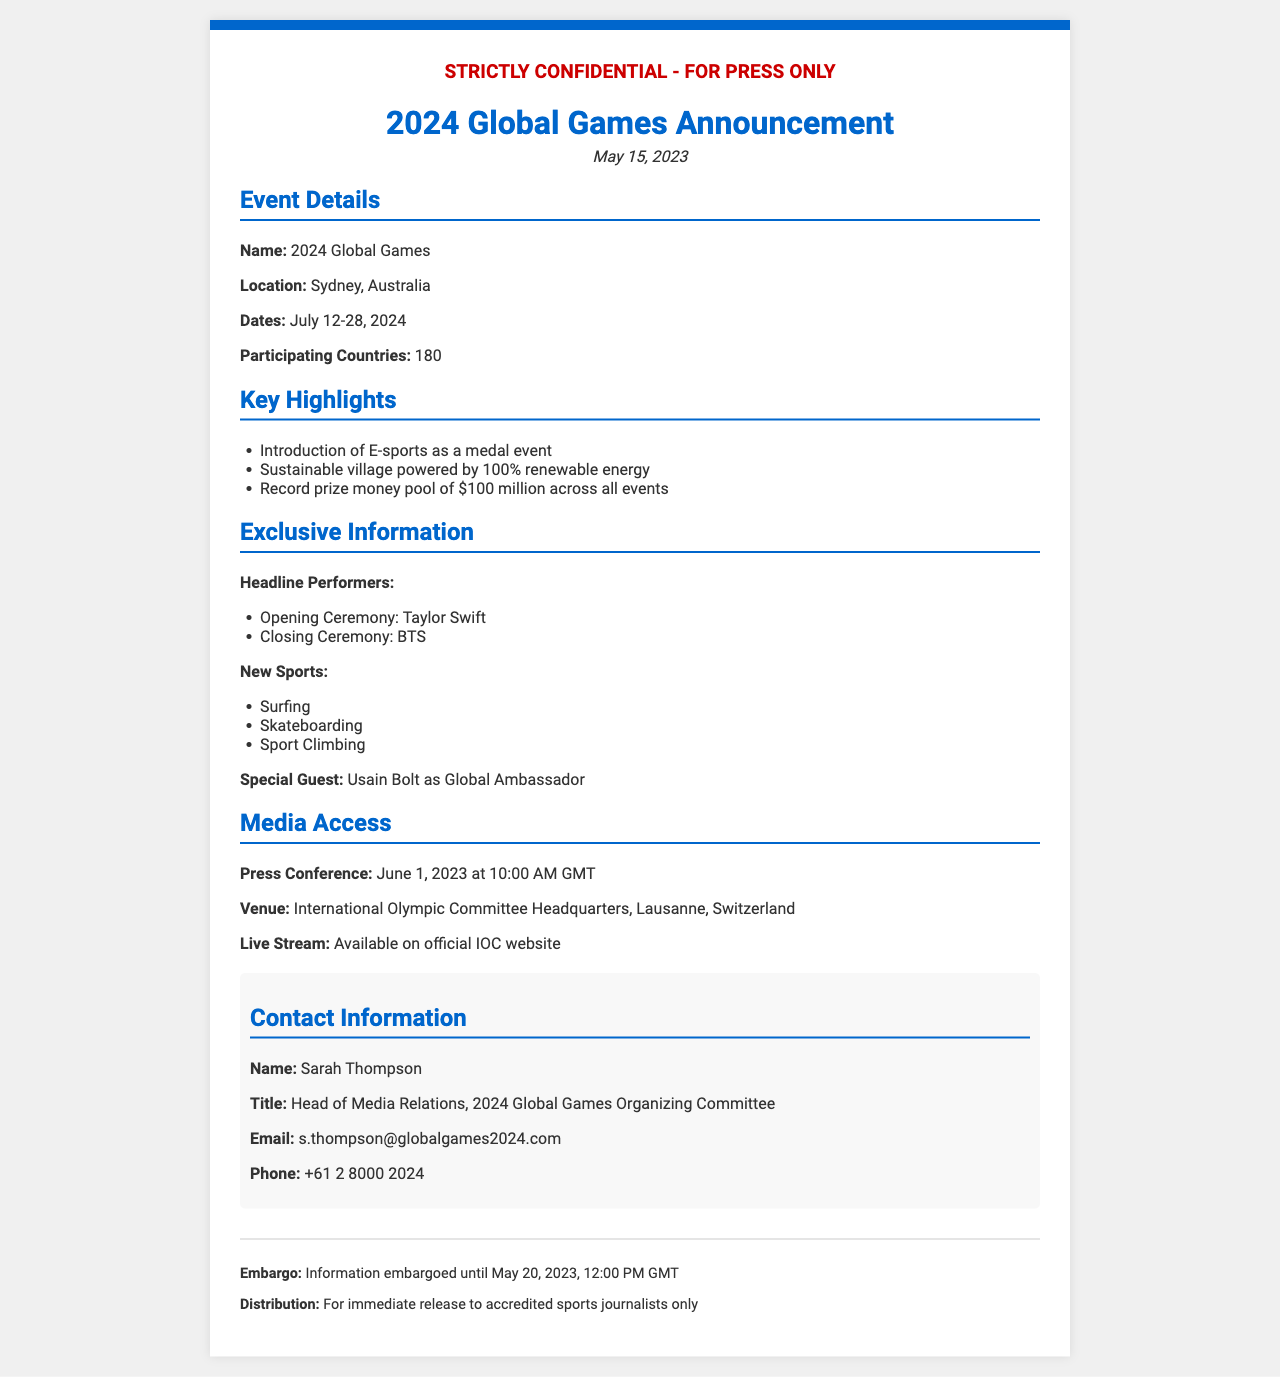What is the name of the event? The name of the event is stated in the document under event details.
Answer: 2024 Global Games Where is the event located? The location of the event is detailed in the event details section.
Answer: Sydney, Australia What are the dates of the event? The dates are specified in the event details section.
Answer: July 12-28, 2024 How many participating countries are there? The document provides this number in the event details.
Answer: 180 Who is performing at the opening ceremony? The headline performer for the opening ceremony is listed in the exclusive information section.
Answer: Taylor Swift What is the total prize money pool? The total prize money pool is mentioned in the key highlights section.
Answer: $100 million What is the special guest's title? The title of the special guest is mentioned in the exclusive information section.
Answer: Global Ambassador When is the press conference scheduled? The date and time of the press conference is mentioned in the media access section.
Answer: June 1, 2023 at 10:00 AM GMT What is the embargo date for the information? The embargo date is specified in the footer of the document.
Answer: May 20, 2023, 12:00 PM GMT 